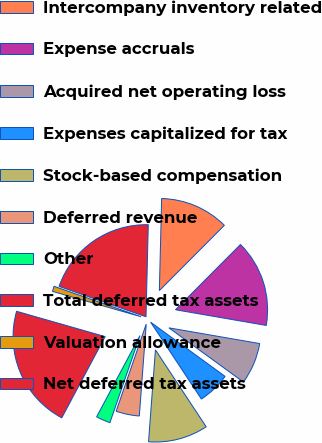Convert chart to OTSL. <chart><loc_0><loc_0><loc_500><loc_500><pie_chart><fcel>Intercompany inventory related<fcel>Expense accruals<fcel>Acquired net operating loss<fcel>Expenses capitalized for tax<fcel>Stock-based compensation<fcel>Deferred revenue<fcel>Other<fcel>Total deferred tax assets<fcel>Valuation allowance<fcel>Net deferred tax assets<nl><fcel>12.07%<fcel>15.26%<fcel>7.29%<fcel>5.7%<fcel>10.48%<fcel>4.1%<fcel>2.51%<fcel>21.63%<fcel>0.92%<fcel>20.04%<nl></chart> 